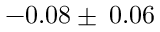Convert formula to latex. <formula><loc_0><loc_0><loc_500><loc_500>- 0 . 0 8 \pm \, 0 . 0 6</formula> 